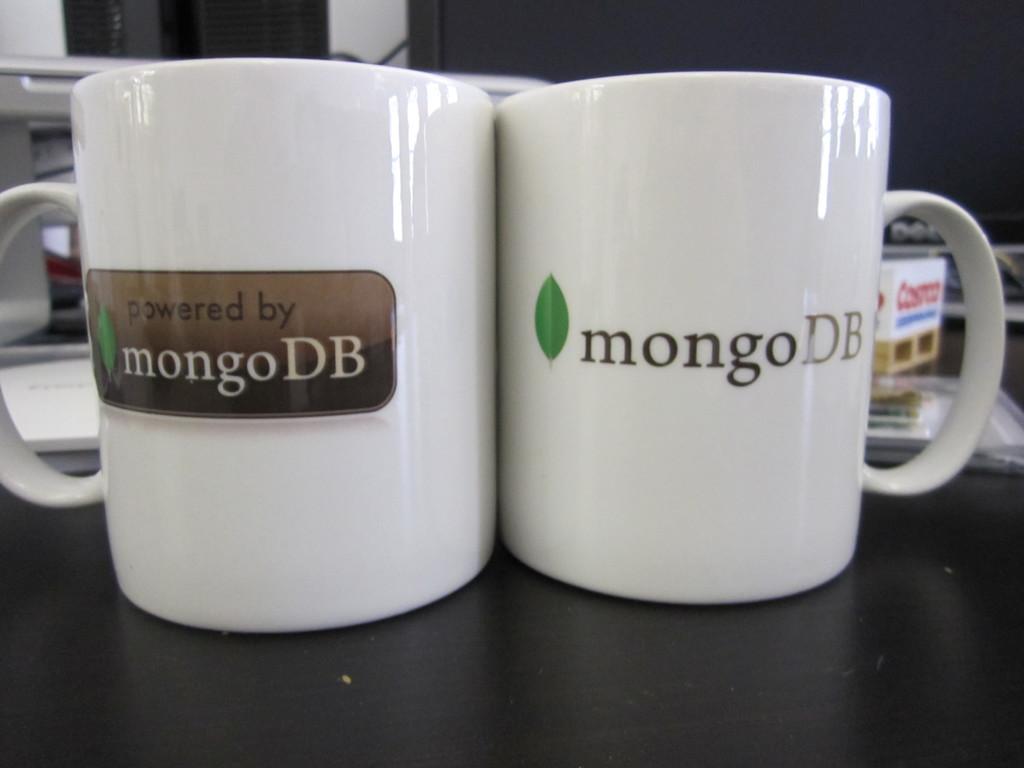What does the cup on the right say?
Ensure brevity in your answer.  Mongodb. The mug on the left says powered by what?
Ensure brevity in your answer.  Mongodb. 